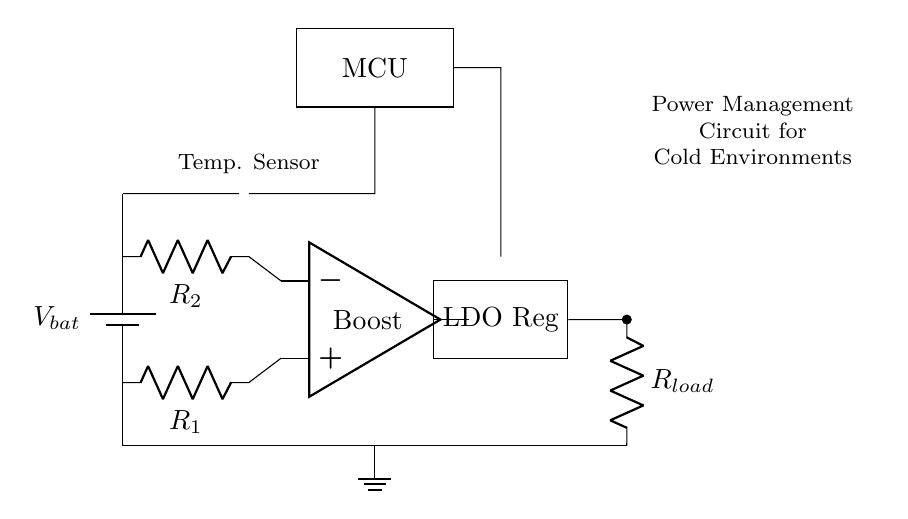What type of battery is used in the circuit? The circuit includes a generic battery symbol, which indicates that it is designed to represent a direct current (DC) battery without specifying a particular type.
Answer: Battery What component is used for temperature sensing? The diagram features a thermistor symbol connected to the battery, indicating its function as a temperature sensor.
Answer: Thermistor What is the function of the boost converter in this circuit? The boost converter is used to increase the voltage from the battery to a higher level required for the load. It is positioned after the temperature sensor and before the voltage regulator in the circuit.
Answer: Voltage boost What does LDO stand for in this power management circuit? LDO is an acronym for Low Drop-Out regulator, which is responsible for maintaining a constant output voltage despite variations in load current, and it is positioned after the boost converter.
Answer: Low Drop-Out How many resistors are present in the circuit and what are their labels? The circuit contains two resistors labeled R1 and R2, which are part of the feedback network to the boost converter, helping to set its output voltage level.
Answer: Two resistors What is the purpose of the MCU in this circuit? The MCU, or Microcontroller Unit, is responsible for managing the power distribution and operation of the rest of the components in the circuit, likely including the temperature sensor and boost converter's operation.
Answer: Management How does the power management circuit aid in cold environments? This circuit likely enhances battery longevity and device performance in low temperatures by using a temperature sensor to regulate voltage levels, allowing continuous operation despite lower battery efficiency in cold.
Answer: Extended battery life 